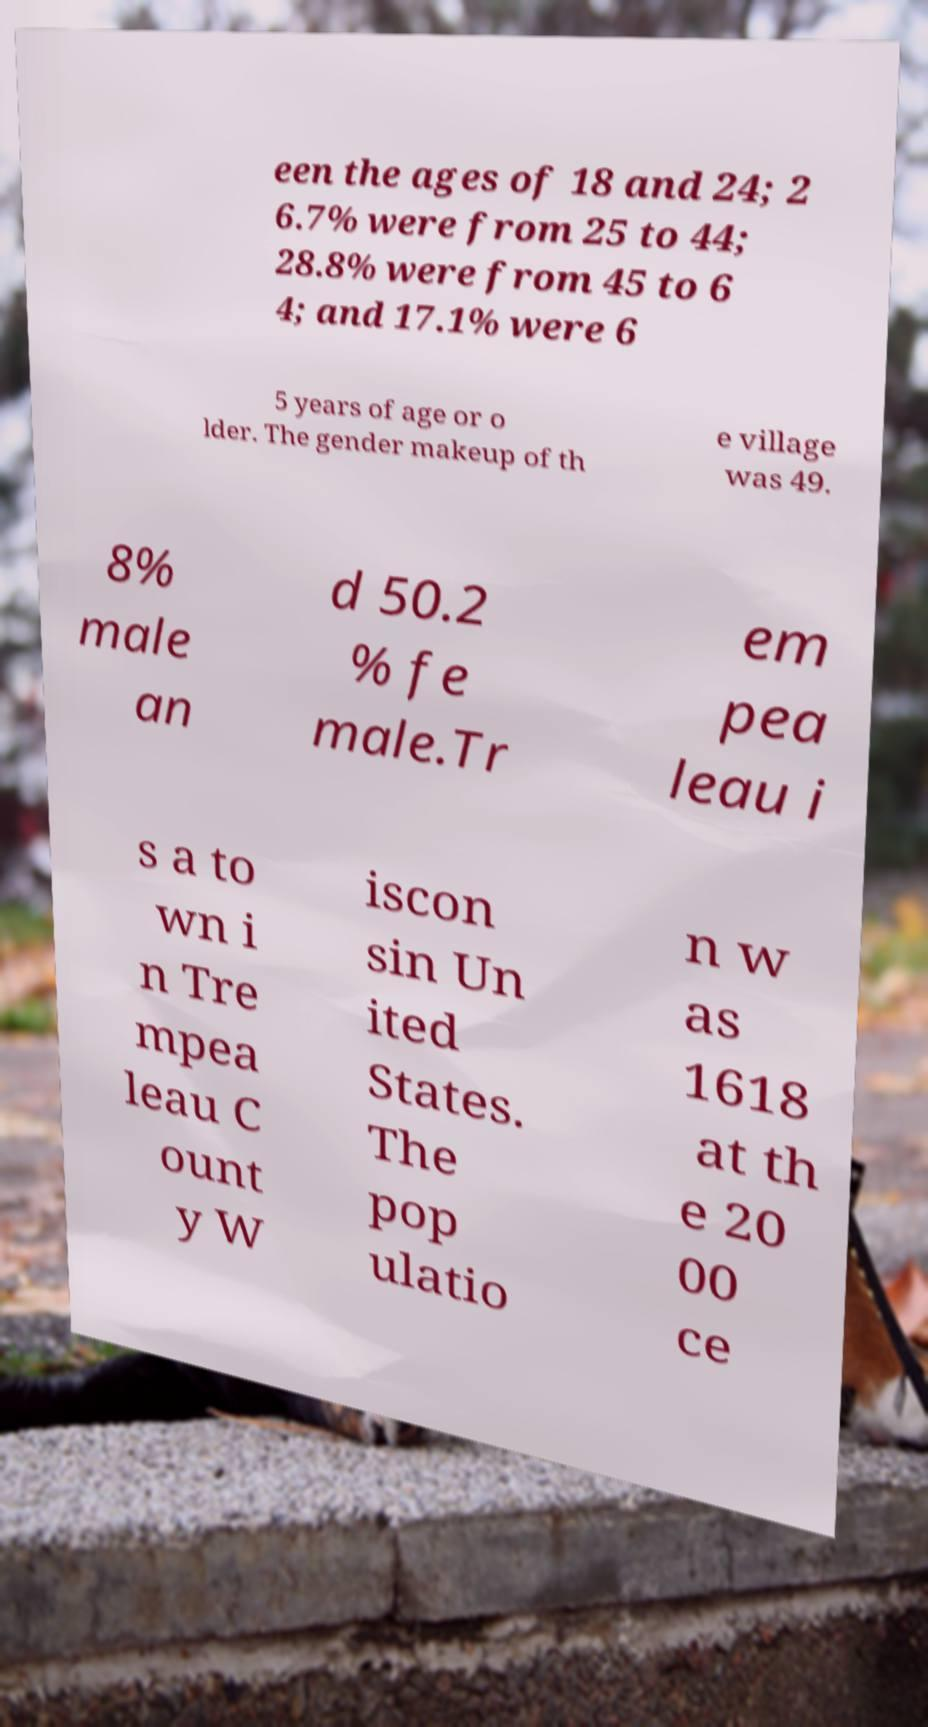There's text embedded in this image that I need extracted. Can you transcribe it verbatim? een the ages of 18 and 24; 2 6.7% were from 25 to 44; 28.8% were from 45 to 6 4; and 17.1% were 6 5 years of age or o lder. The gender makeup of th e village was 49. 8% male an d 50.2 % fe male.Tr em pea leau i s a to wn i n Tre mpea leau C ount y W iscon sin Un ited States. The pop ulatio n w as 1618 at th e 20 00 ce 